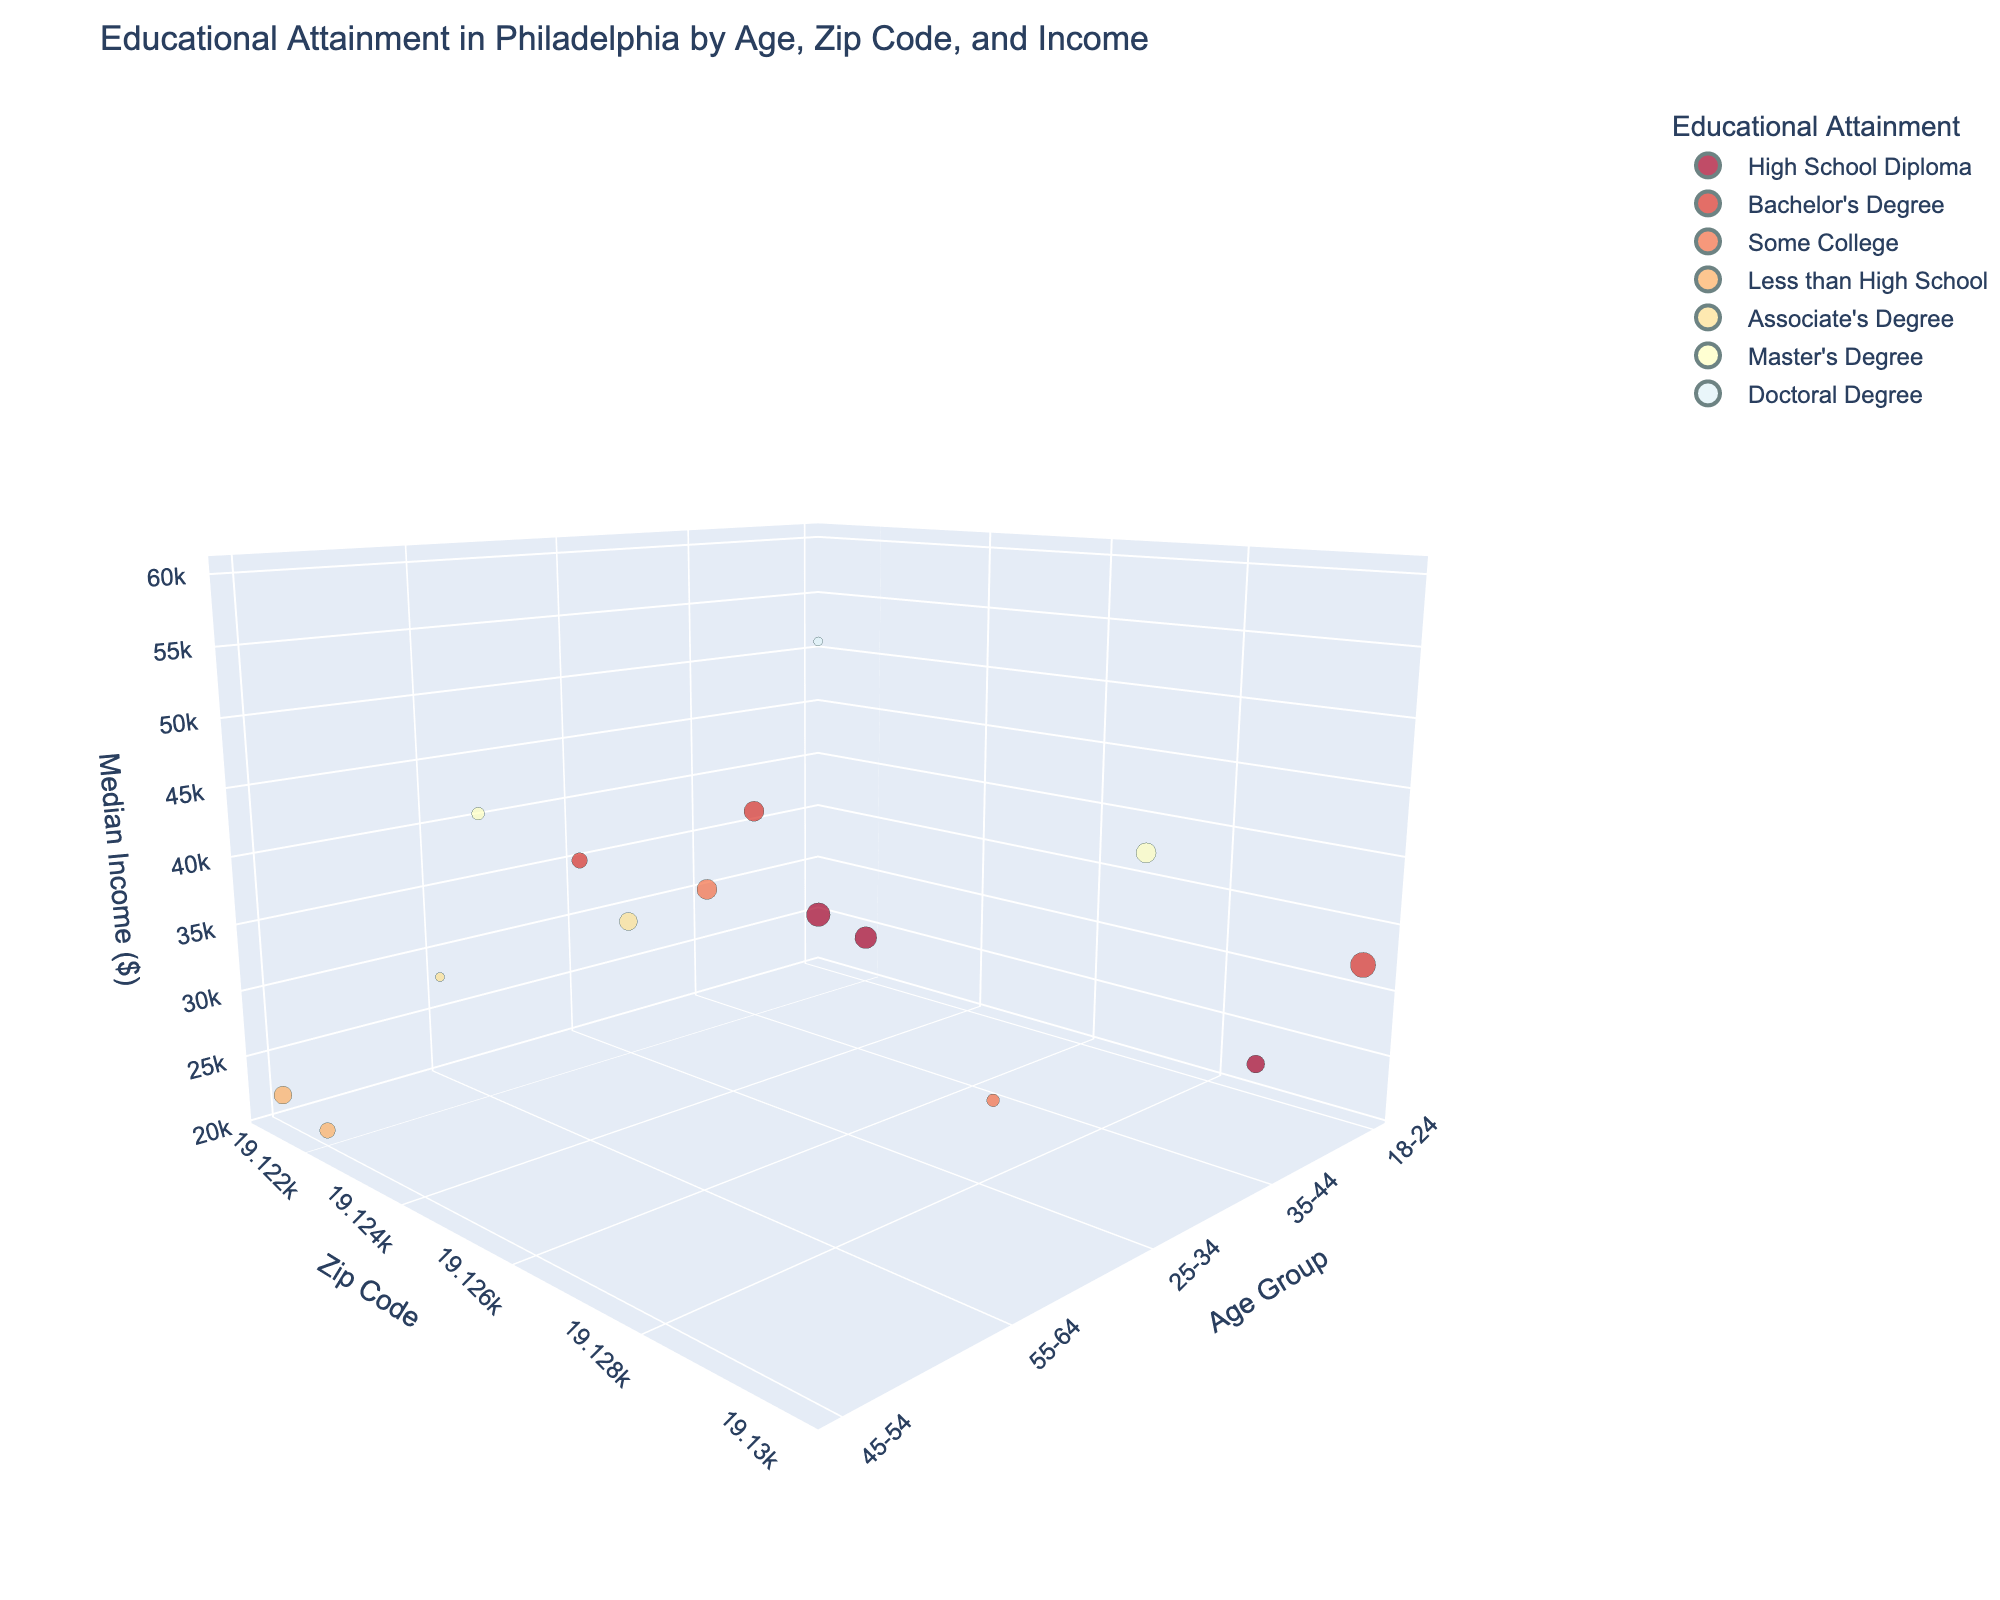What's the highest median income recorded in the 19130 zip code? Look at the points in the figure where the zip code is 19130 and identify the one with the highest z-value (Median Income).
Answer: $60,000 What age group has the highest population percentage for high school diploma in zip code 19121? Filter by zip code 19121 and educational attainment 'High School Diploma'. Then check which age group has the point with the largest bubble size.
Answer: 18-24 How does the median income of 18-24 year-olds in zip code 19121 compare to those in zip code 19122? Compare the z-values (Median Income) of the bubbles for age group 18-24 in zip codes 19121 and 19122.
Answer: 19121: $25,000, 19122: $24,000 In zip code 19122, which age group has the lowest median income and what is the educational attainment associated with it? Locate the points in the figure for zip code 19122 and compare their z-values (Median Income). Identify the point with the lowest and check the corresponding age group and color (Educational Attainment).
Answer: 45-54, Less than High School Which educational attainment has a median income of about $42,000, and in what zip code and age group is it located? Look for a bubble with a z-value (Median Income) close to $42,000 and read its associated educational attainment, zip code, and age group.
Answer: Master's Degree, 55-64, 19122 Which age group in zip code 19130 has the largest bubble size, and what educational attainment do they have? Look at the bubbles in zip code 19130 and identify the one with the largest size. Check the associated age group and color for educational attainment.
Answer: 18-24, Bachelor's Degree Compare the median incomes of bachelor's degree holders across zip codes 19121, 19130, and 19122. Which zip code has the highest and the lowest median income? Find the bubbles for bachelor's degree in each specified zip code and compare their z-values (Median Income).
Answer: Highest: 19122 ($38,000), Lowest: 19121 ($35,000) How many educational attainment levels are represented in zip code 19121? Count the unique colors (Educational Attainment) in the bubbles for zip code 19121.
Answer: 5 What's the overall trend in median income as the educational attainment level increases in zip code 19130? Observe the z-values (Median Income) in zip code 19130 corresponding to different educational attainment levels and recognize the pattern.
Answer: Increasing 